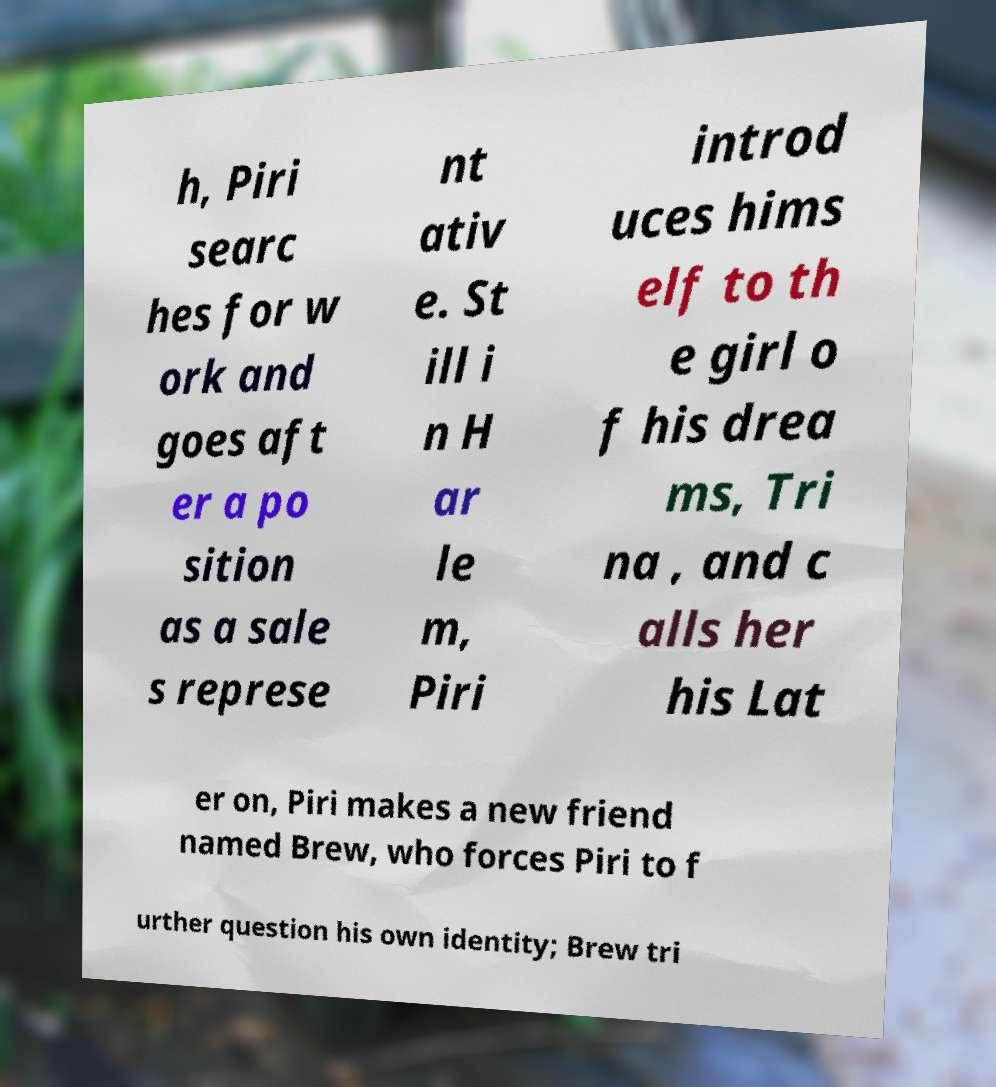There's text embedded in this image that I need extracted. Can you transcribe it verbatim? h, Piri searc hes for w ork and goes aft er a po sition as a sale s represe nt ativ e. St ill i n H ar le m, Piri introd uces hims elf to th e girl o f his drea ms, Tri na , and c alls her his Lat er on, Piri makes a new friend named Brew, who forces Piri to f urther question his own identity; Brew tri 